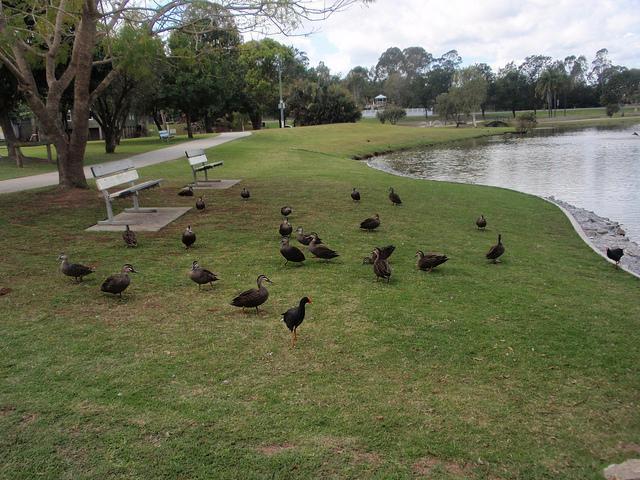How many benches?
Give a very brief answer. 2. 